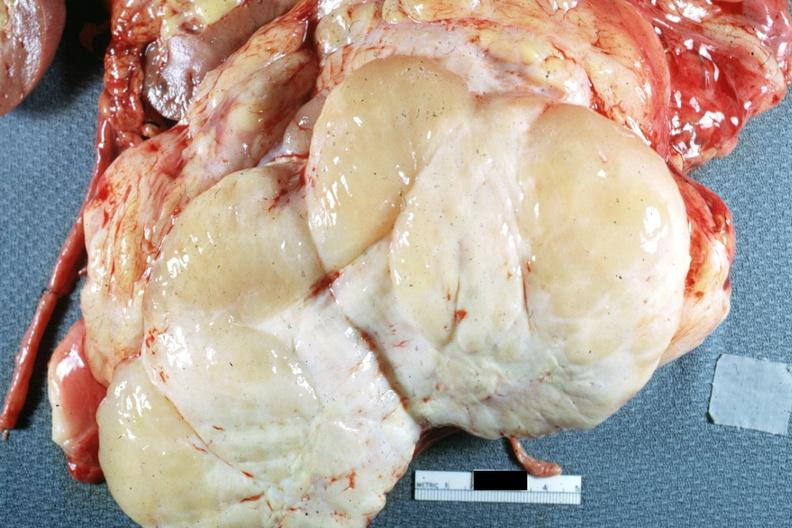what is present?
Answer the question using a single word or phrase. Abdomen 